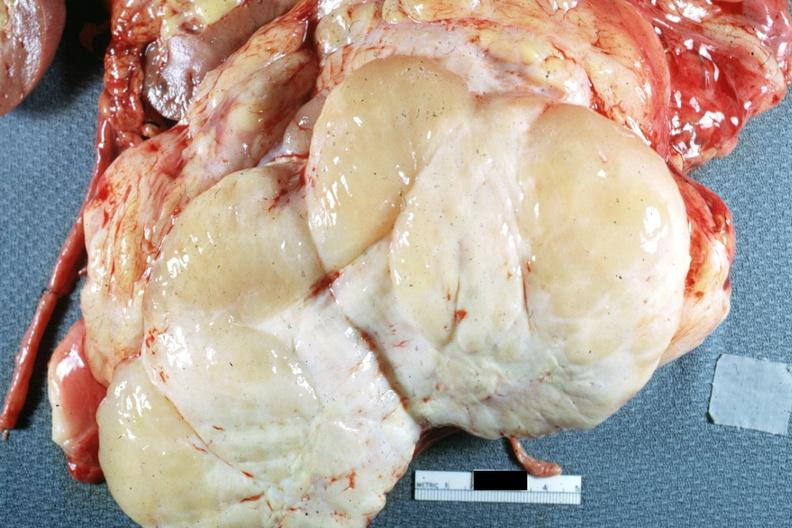what is present?
Answer the question using a single word or phrase. Abdomen 